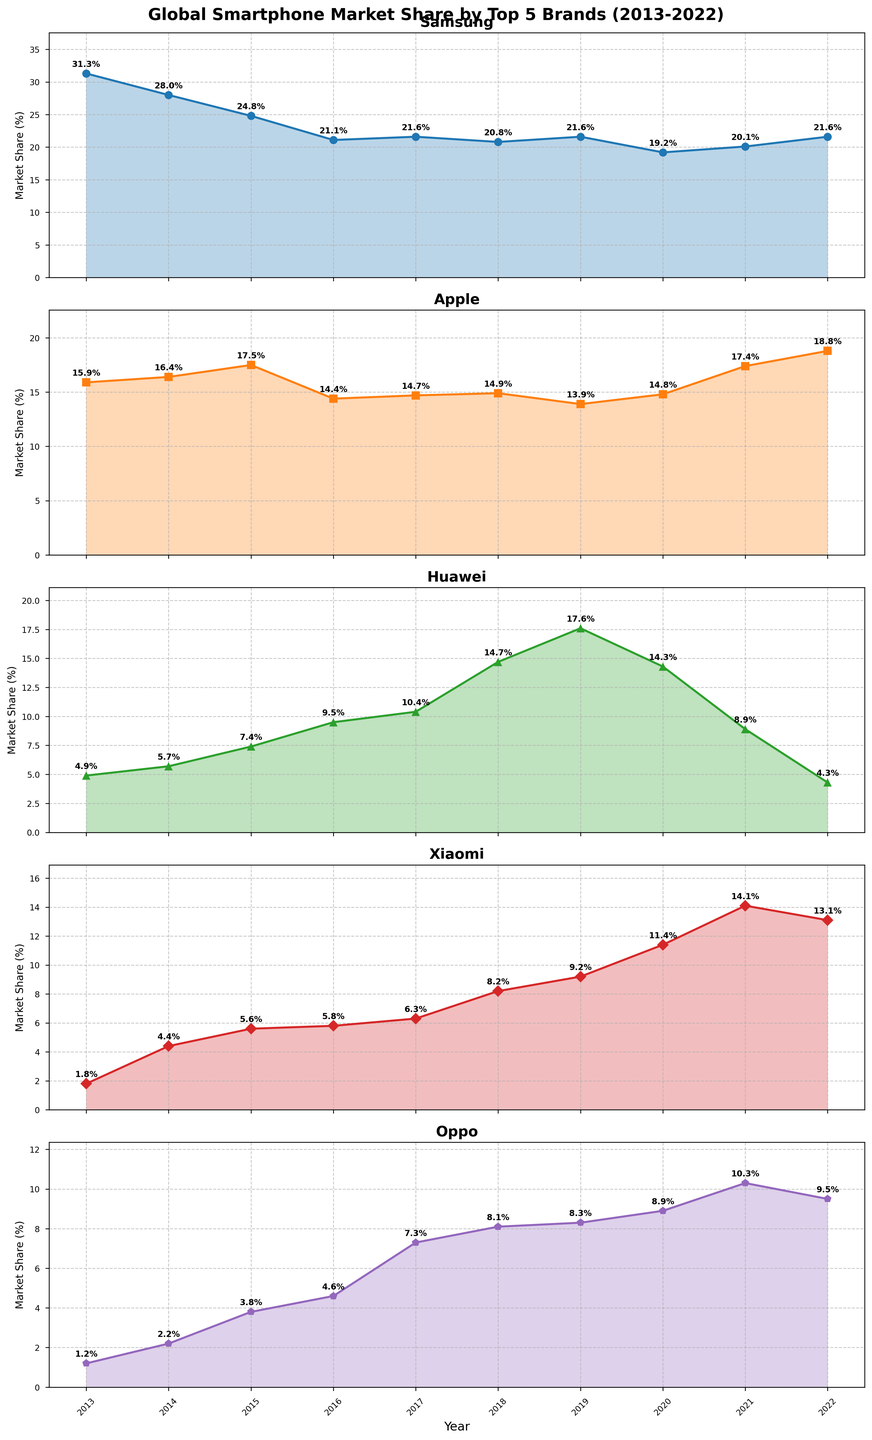Which brand had the most stable market share over the decade? By looking at the plots, a stable market share is indicated by smaller fluctuations in the line. Samsung's plot shows the least fluctuation compared to other brands.
Answer: Samsung Which year did Apple have the highest market share, and what was that share? By examining Apple's plot, the peak market share was in 2022. Annotate the value at the peak to find it was 18.8%.
Answer: 2022, 18.8% Between 2019 and 2021, which brand had the largest decrease in market share? Calculate the market share difference for each brand between 2019 and 2021. Huawei dropped from 17.6% to 8.9%, a decrease of 8.7%.
Answer: Huawei What was the average market share of Xiaomi from 2013 to 2022? Sum up Xiaomi's market share values and divide by the number of years. (1.8+4.4+5.6+5.8+6.3+8.2+9.2+11.4+14.1+13.1) / 10 = 7.99 rounded to 8.0%.
Answer: 8.0% Which year did Huawei surpass Apple in market share, and by how much? Look at Huawei's and Apple's plots and find the year when Huawei's line goes above Apple's. In 2019, Huawei had 17.6% versus Apple's 13.9%, exceeding Apple by 3.7%.
Answer: 2019, 3.7% Which brand's market share increased the most from 2013 to 2020? Calculate the market share increase for each brand from 2013 to 2020. Xiaomi's share increased from 1.8% to 11.4%, an increase of 9.6%.
Answer: Xiaomi Which years did Oppo's market share peak, and what was the percentage? Find the peak in Oppo's plot by looking for the highest annotated value, which is in 2021 at 10.3%.
Answer: 2021, 10.3% Between Samsung and Apple, which had a greater decline from their highest to lowest market share, and what was that decline? Calculate Samsung’s maximum (31.3%) and minimum (19.2%) share, a decline of 12.1%. For Apple, from 18.8% to 13.9%, a decline of 4.9%.
Answer: Samsung, 12.1% decline Which two brands had an almost similar market share at any year and in which year? Look for years where plots of two brands are very close. In 2018, Huawei (14.7%) and Apple (14.9%) were almost similar.
Answer: Huawei and Apple, 2018 